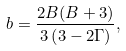<formula> <loc_0><loc_0><loc_500><loc_500>b = \frac { 2 B ( B + 3 ) } { 3 \left ( 3 - 2 \Gamma \right ) } ,</formula> 